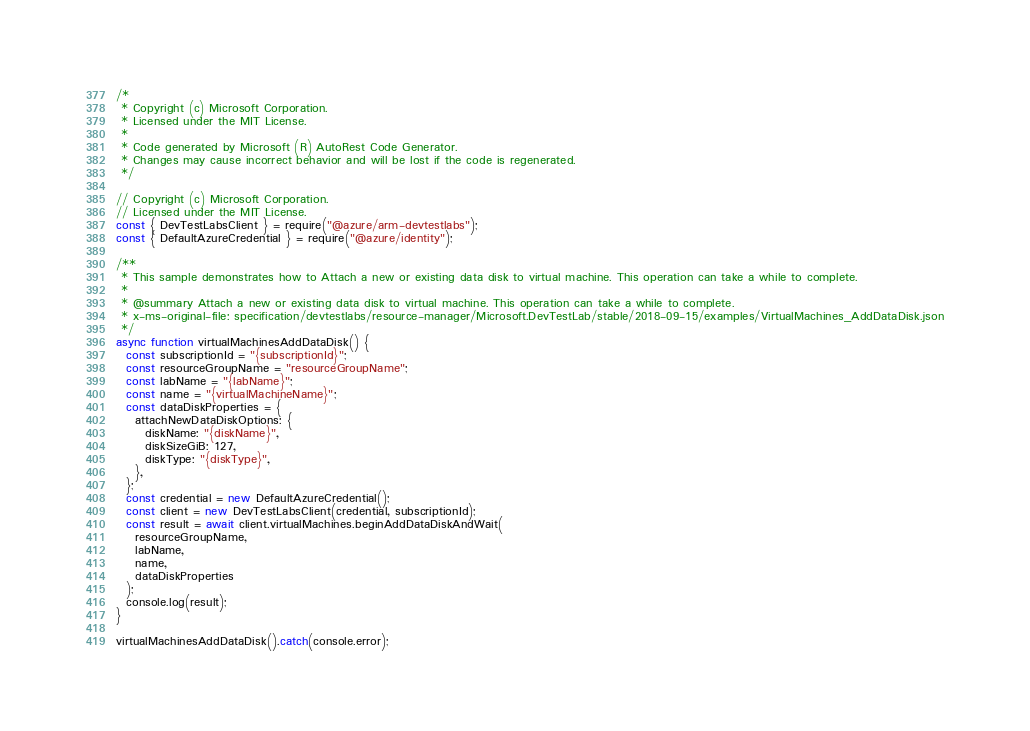<code> <loc_0><loc_0><loc_500><loc_500><_JavaScript_>/*
 * Copyright (c) Microsoft Corporation.
 * Licensed under the MIT License.
 *
 * Code generated by Microsoft (R) AutoRest Code Generator.
 * Changes may cause incorrect behavior and will be lost if the code is regenerated.
 */

// Copyright (c) Microsoft Corporation.
// Licensed under the MIT License.
const { DevTestLabsClient } = require("@azure/arm-devtestlabs");
const { DefaultAzureCredential } = require("@azure/identity");

/**
 * This sample demonstrates how to Attach a new or existing data disk to virtual machine. This operation can take a while to complete.
 *
 * @summary Attach a new or existing data disk to virtual machine. This operation can take a while to complete.
 * x-ms-original-file: specification/devtestlabs/resource-manager/Microsoft.DevTestLab/stable/2018-09-15/examples/VirtualMachines_AddDataDisk.json
 */
async function virtualMachinesAddDataDisk() {
  const subscriptionId = "{subscriptionId}";
  const resourceGroupName = "resourceGroupName";
  const labName = "{labName}";
  const name = "{virtualMachineName}";
  const dataDiskProperties = {
    attachNewDataDiskOptions: {
      diskName: "{diskName}",
      diskSizeGiB: 127,
      diskType: "{diskType}",
    },
  };
  const credential = new DefaultAzureCredential();
  const client = new DevTestLabsClient(credential, subscriptionId);
  const result = await client.virtualMachines.beginAddDataDiskAndWait(
    resourceGroupName,
    labName,
    name,
    dataDiskProperties
  );
  console.log(result);
}

virtualMachinesAddDataDisk().catch(console.error);
</code> 